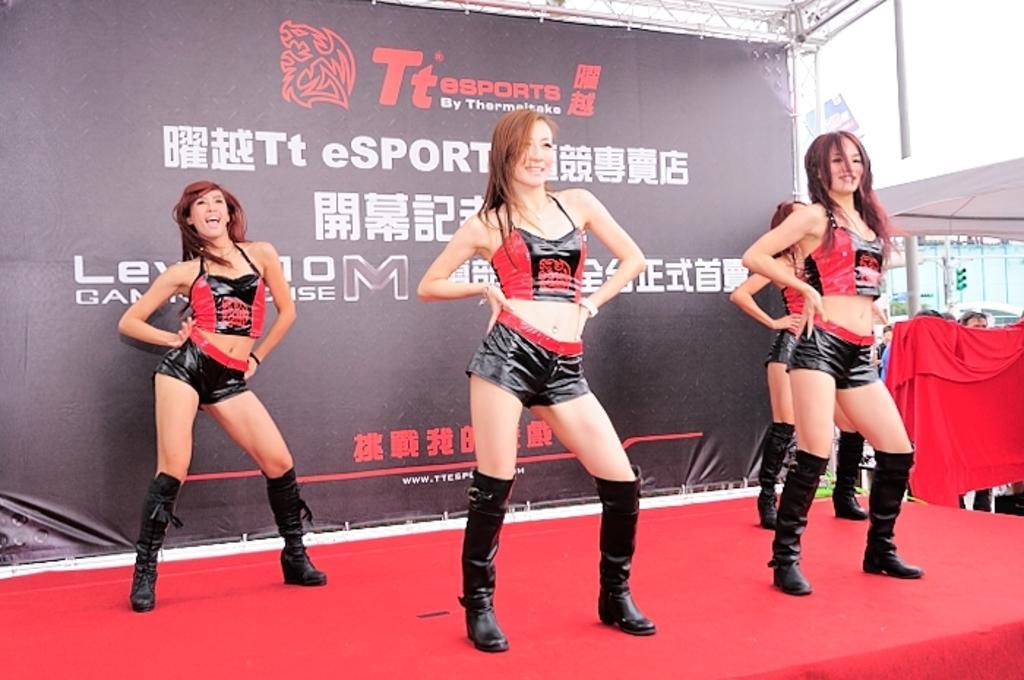Describe this image in one or two sentences. In this image I can see four women's are performing a dance on the stage. In the background I can see a hoarding, shed, water, the sky and a group of people are standing on the ground. This image is taken may be during a day. 